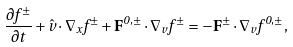<formula> <loc_0><loc_0><loc_500><loc_500>\frac { \partial f ^ { \pm } } { \partial t } + \hat { v } \cdot \nabla _ { x } f ^ { \pm } + \mathbf F ^ { 0 , \pm } \cdot \nabla _ { v } f ^ { \pm } = - \mathbf F ^ { \pm } \cdot \nabla _ { v } f ^ { 0 , \pm } ,</formula> 